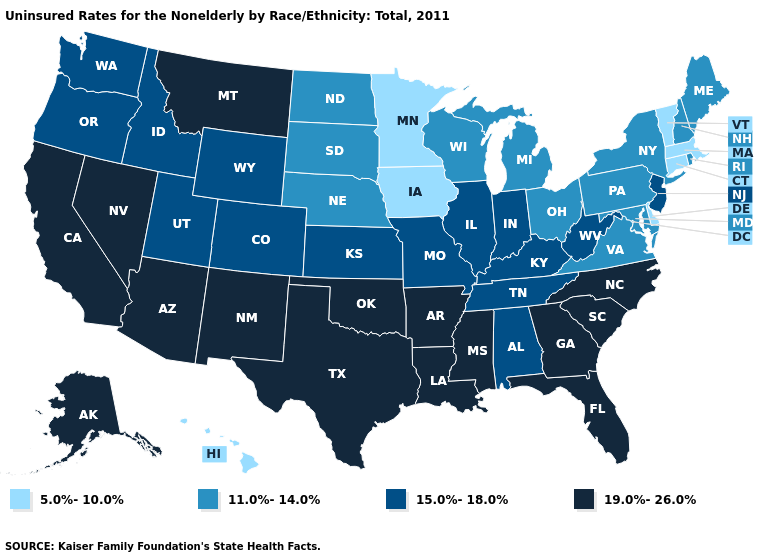Among the states that border Idaho , does Nevada have the highest value?
Give a very brief answer. Yes. Name the states that have a value in the range 19.0%-26.0%?
Keep it brief. Alaska, Arizona, Arkansas, California, Florida, Georgia, Louisiana, Mississippi, Montana, Nevada, New Mexico, North Carolina, Oklahoma, South Carolina, Texas. Among the states that border Indiana , does Illinois have the lowest value?
Answer briefly. No. Does New York have the lowest value in the USA?
Be succinct. No. What is the highest value in the Northeast ?
Give a very brief answer. 15.0%-18.0%. Does Minnesota have the highest value in the MidWest?
Quick response, please. No. What is the highest value in states that border West Virginia?
Short answer required. 15.0%-18.0%. What is the lowest value in the USA?
Answer briefly. 5.0%-10.0%. What is the value of Arizona?
Answer briefly. 19.0%-26.0%. What is the highest value in the USA?
Quick response, please. 19.0%-26.0%. Does Minnesota have the lowest value in the USA?
Be succinct. Yes. What is the value of North Dakota?
Answer briefly. 11.0%-14.0%. Among the states that border Indiana , does Kentucky have the lowest value?
Be succinct. No. Among the states that border Iowa , which have the highest value?
Short answer required. Illinois, Missouri. Name the states that have a value in the range 11.0%-14.0%?
Keep it brief. Maine, Maryland, Michigan, Nebraska, New Hampshire, New York, North Dakota, Ohio, Pennsylvania, Rhode Island, South Dakota, Virginia, Wisconsin. 